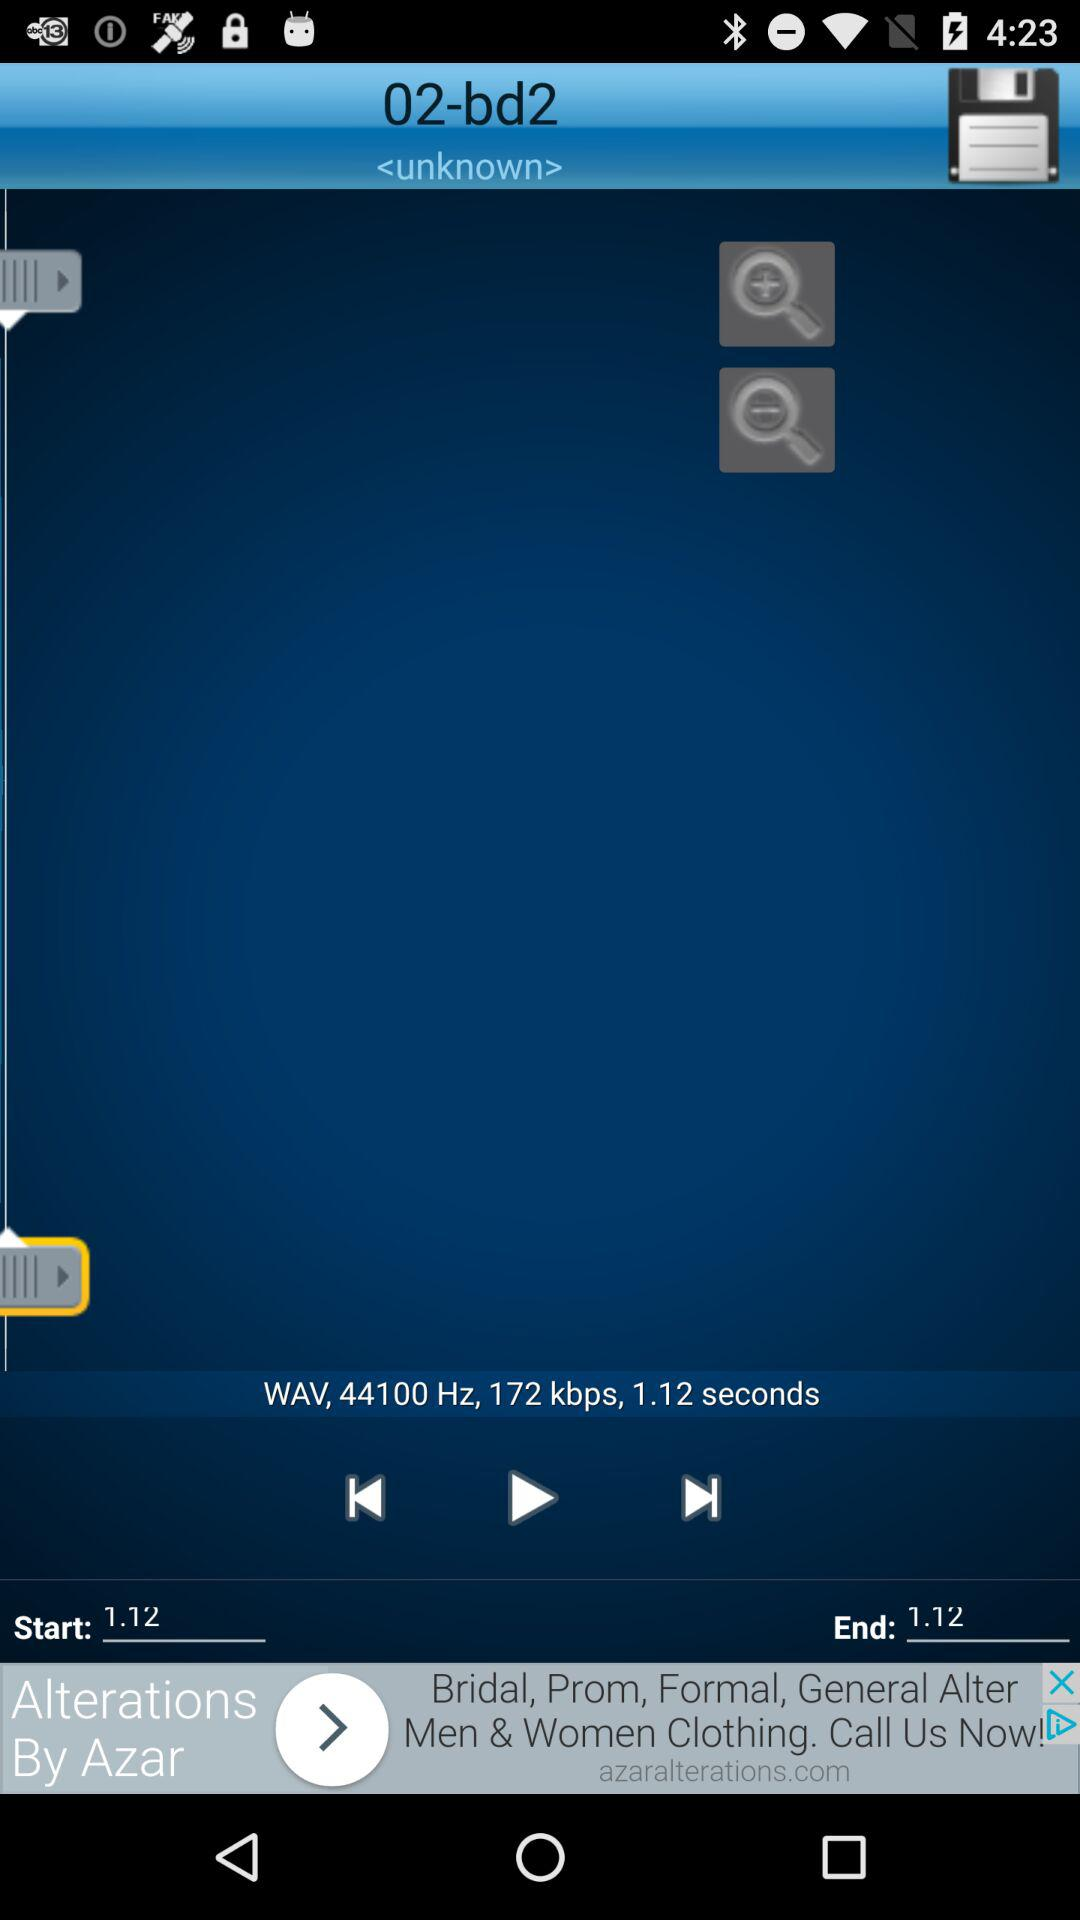What is the frequency? The frequency is 44100 Hz. 